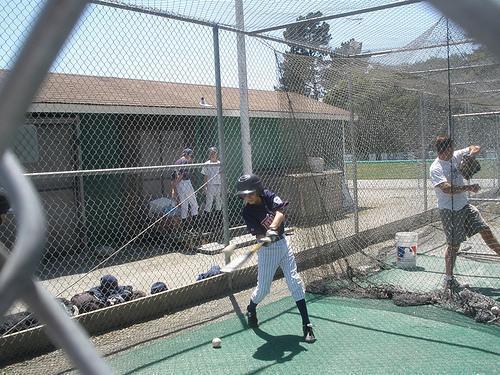How many people can you see?
Give a very brief answer. 2. 